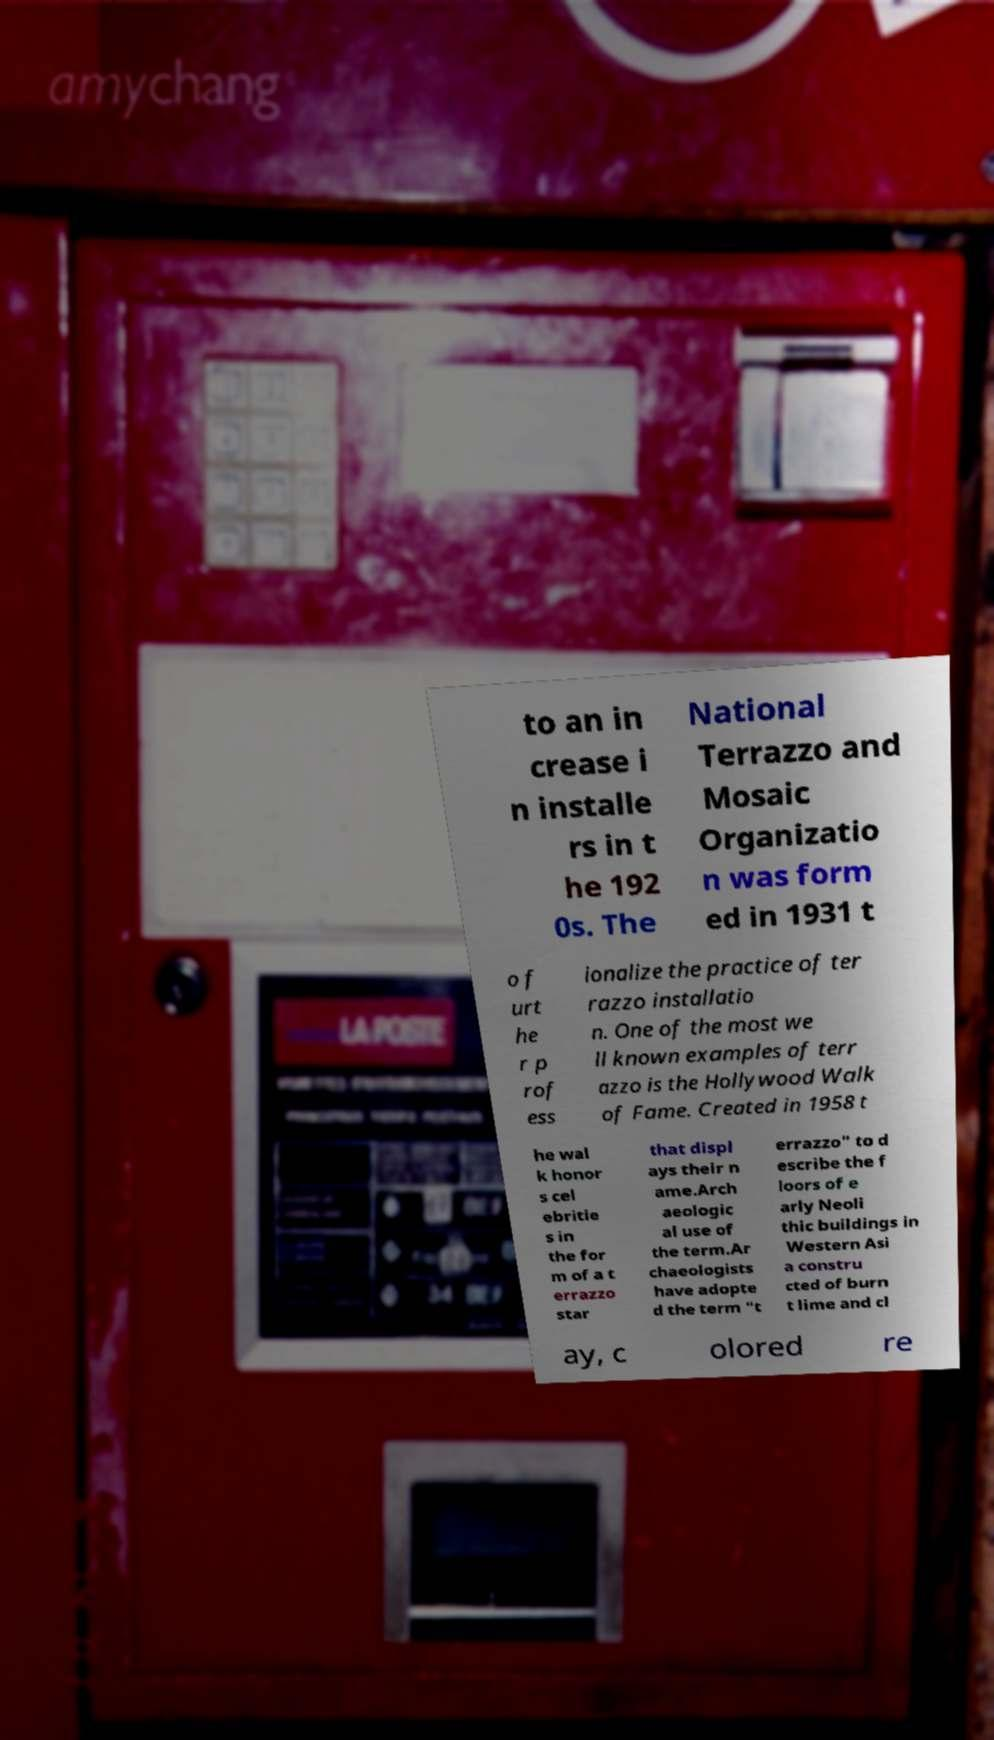For documentation purposes, I need the text within this image transcribed. Could you provide that? to an in crease i n installe rs in t he 192 0s. The National Terrazzo and Mosaic Organizatio n was form ed in 1931 t o f urt he r p rof ess ionalize the practice of ter razzo installatio n. One of the most we ll known examples of terr azzo is the Hollywood Walk of Fame. Created in 1958 t he wal k honor s cel ebritie s in the for m of a t errazzo star that displ ays their n ame.Arch aeologic al use of the term.Ar chaeologists have adopte d the term "t errazzo" to d escribe the f loors of e arly Neoli thic buildings in Western Asi a constru cted of burn t lime and cl ay, c olored re 